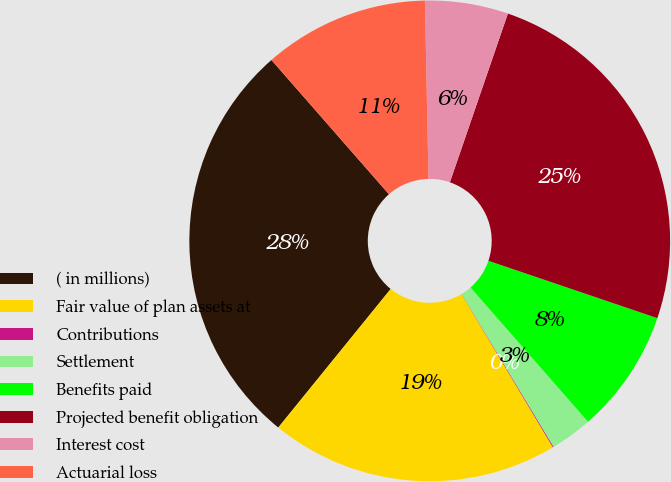Convert chart. <chart><loc_0><loc_0><loc_500><loc_500><pie_chart><fcel>( in millions)<fcel>Fair value of plan assets at<fcel>Contributions<fcel>Settlement<fcel>Benefits paid<fcel>Projected benefit obligation<fcel>Interest cost<fcel>Actuarial loss<nl><fcel>27.71%<fcel>19.41%<fcel>0.06%<fcel>2.82%<fcel>8.35%<fcel>24.94%<fcel>5.59%<fcel>11.12%<nl></chart> 